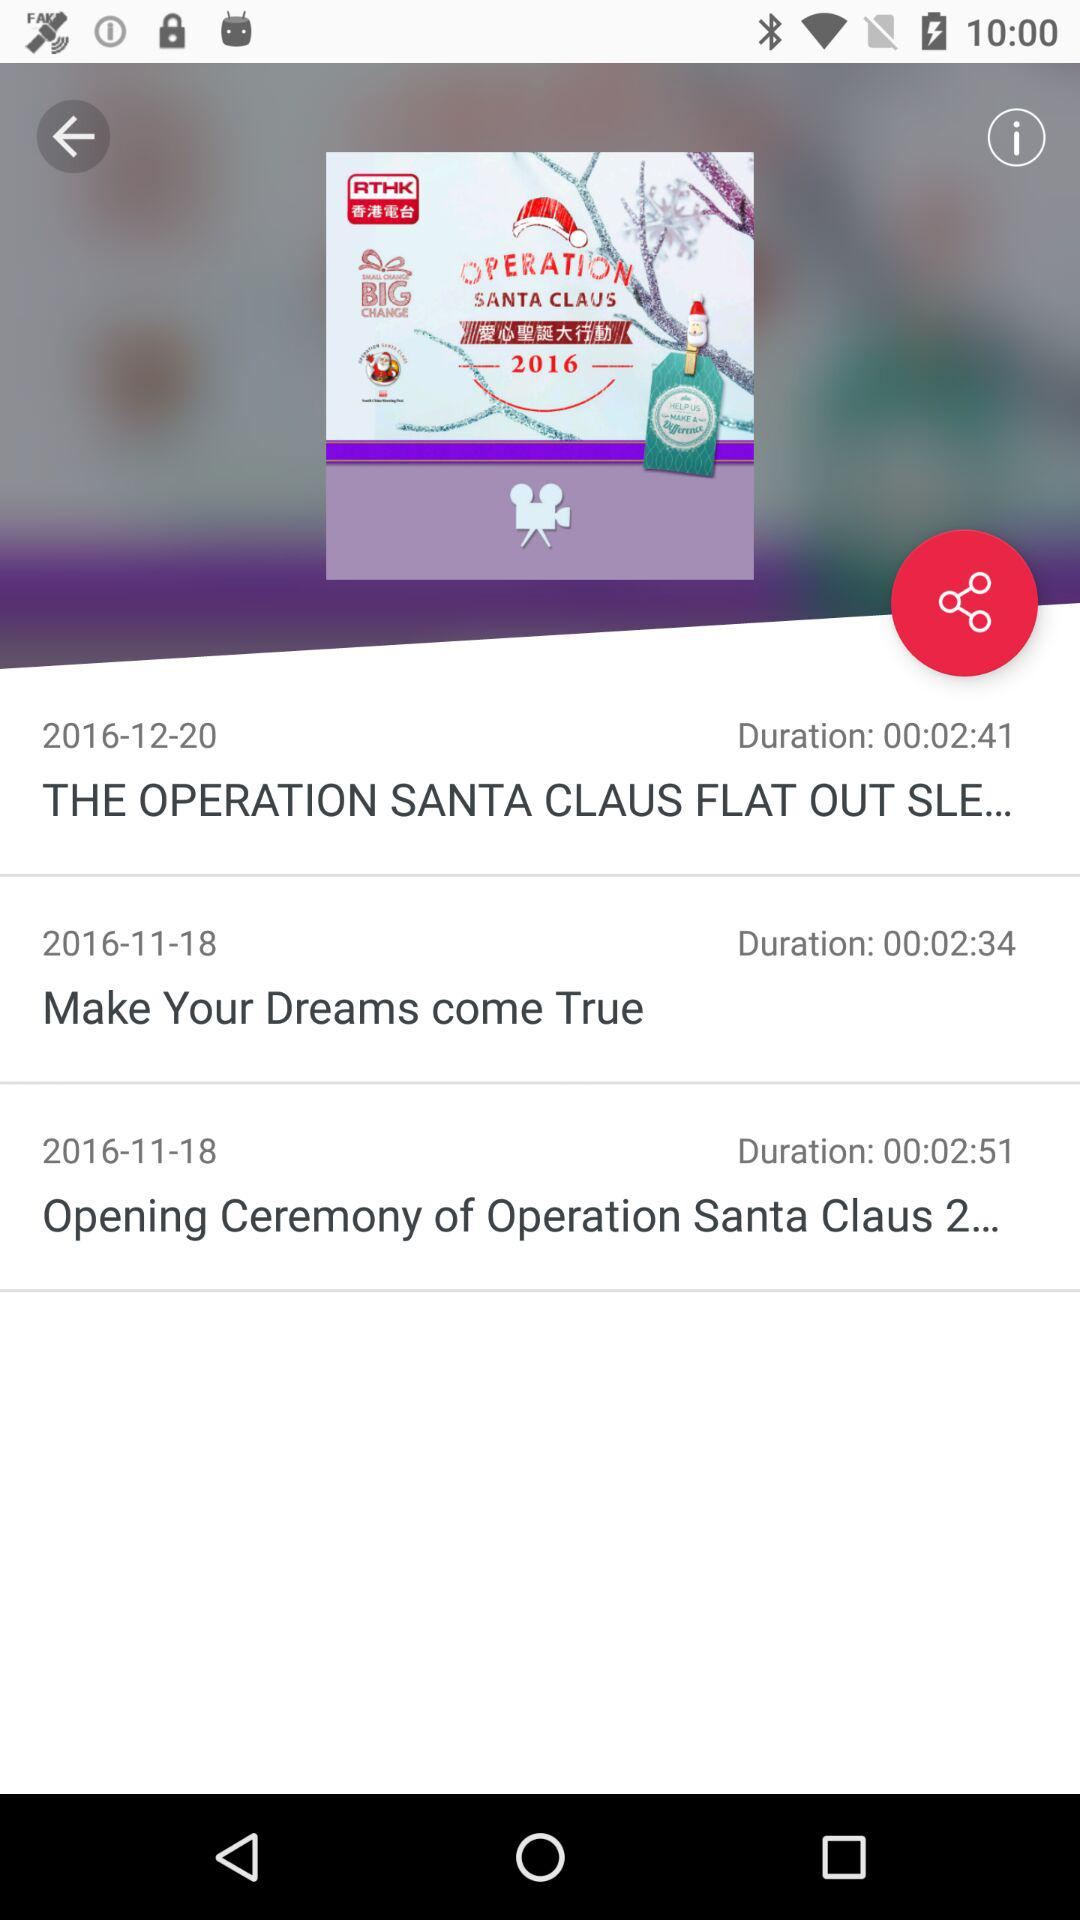What is the date of make your dreams come true? The date is November 18, 2016. 